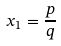<formula> <loc_0><loc_0><loc_500><loc_500>x _ { 1 } = \frac { p } { q }</formula> 